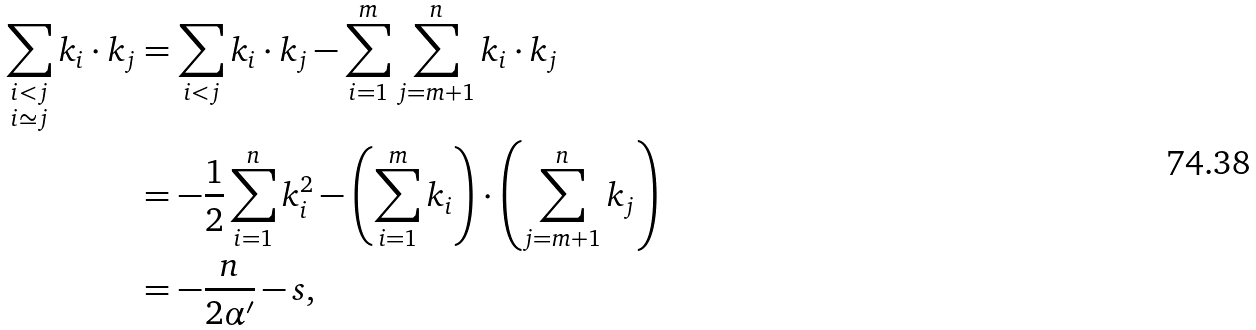<formula> <loc_0><loc_0><loc_500><loc_500>\sum _ { \substack { i < j \\ i \simeq j } } k _ { i } \cdot k _ { j } & = \sum _ { i < j } k _ { i } \cdot k _ { j } - \sum _ { i = 1 } ^ { m } \sum _ { j = m + 1 } ^ { n } k _ { i } \cdot k _ { j } \\ & = - \frac { 1 } { 2 } \sum _ { i = 1 } ^ { n } k _ { i } ^ { 2 } - \left ( \sum _ { i = 1 } ^ { m } k _ { i } \right ) \cdot \left ( \sum _ { j = m + 1 } ^ { n } k _ { j } \right ) \\ & = - \frac { n } { 2 \alpha ^ { \prime } } - s ,</formula> 